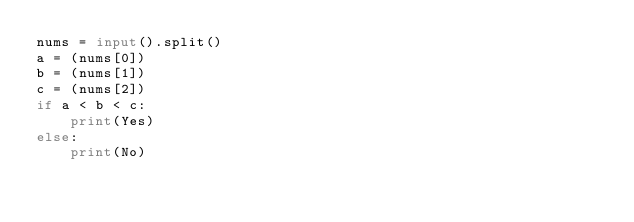<code> <loc_0><loc_0><loc_500><loc_500><_Python_>nums = input().split()
a = (nums[0])
b = (nums[1])
c = (nums[2])
if a < b < c:
    print(Yes)
else:
    print(No)</code> 